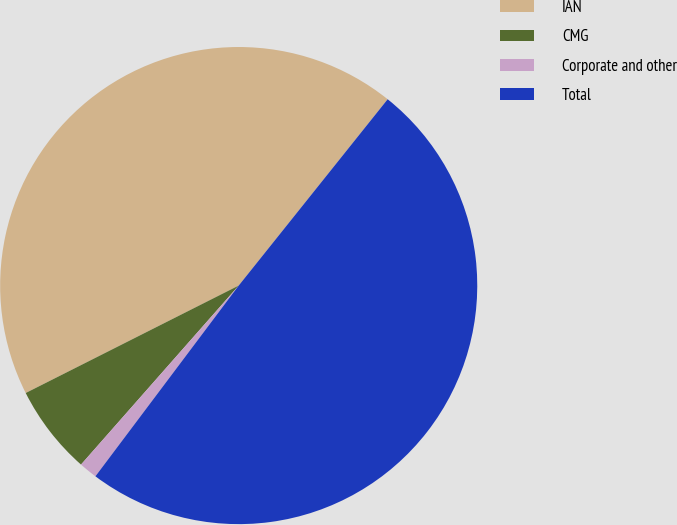Convert chart to OTSL. <chart><loc_0><loc_0><loc_500><loc_500><pie_chart><fcel>IAN<fcel>CMG<fcel>Corporate and other<fcel>Total<nl><fcel>43.17%<fcel>6.07%<fcel>1.24%<fcel>49.52%<nl></chart> 